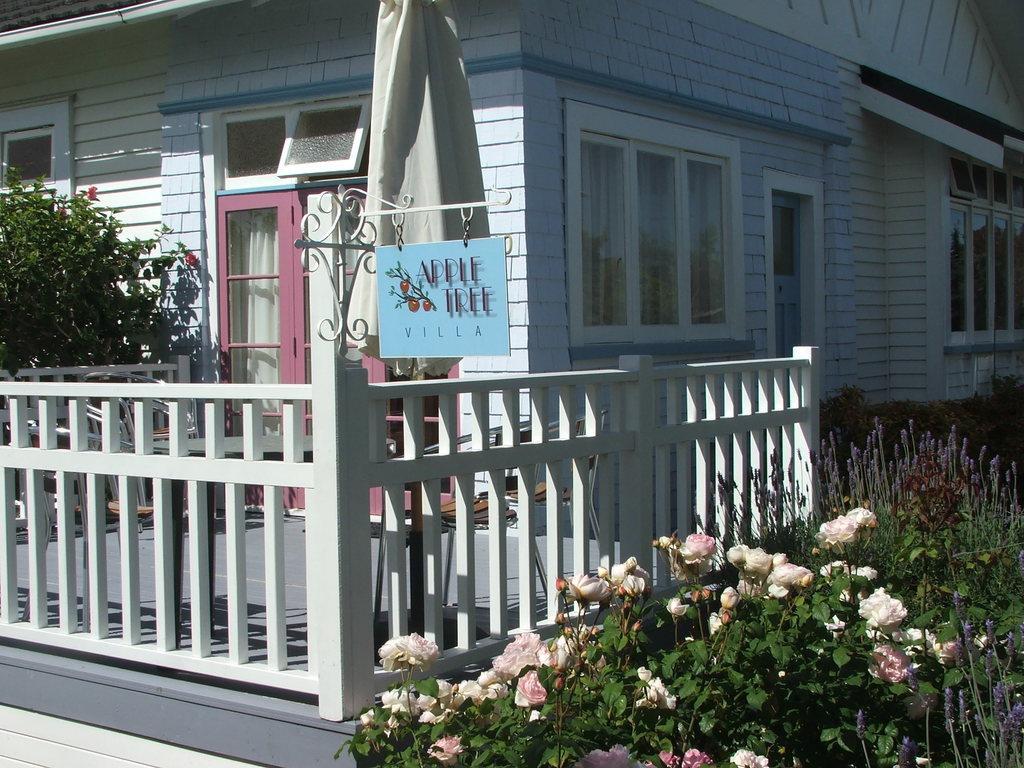Please provide a concise description of this image. At the bottom of the picture, we see the plants which have flowers and these flowers are in white and pink color. Behind that, we see a railing in white color. We see a stand and a board in blue color with some text written on it. On the left side, we see the plants which have red color flowers. In the middle of the picture, we see a building in white color. It has, a pink door, white curtain and the windows. On the right side, we see the plants and a building in white color. It has the windows. 